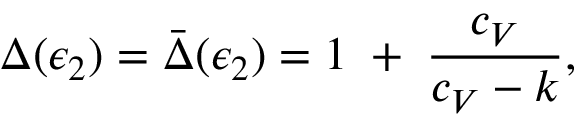Convert formula to latex. <formula><loc_0><loc_0><loc_500><loc_500>\Delta ( \epsilon _ { 2 } ) = \bar { \Delta } ( \epsilon _ { 2 } ) = 1 \, + \, { \frac { c _ { V } } { c _ { V } - k } } ,</formula> 